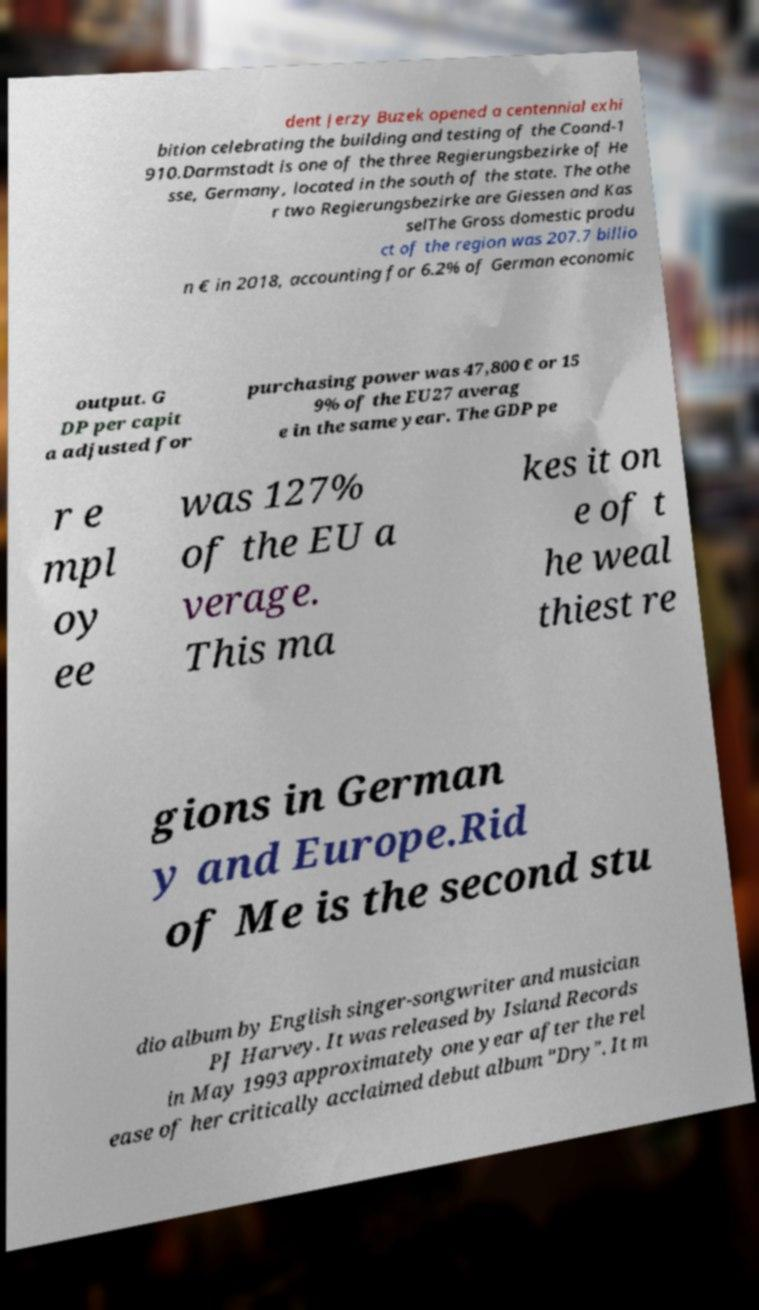For documentation purposes, I need the text within this image transcribed. Could you provide that? dent Jerzy Buzek opened a centennial exhi bition celebrating the building and testing of the Coand-1 910.Darmstadt is one of the three Regierungsbezirke of He sse, Germany, located in the south of the state. The othe r two Regierungsbezirke are Giessen and Kas selThe Gross domestic produ ct of the region was 207.7 billio n € in 2018, accounting for 6.2% of German economic output. G DP per capit a adjusted for purchasing power was 47,800 € or 15 9% of the EU27 averag e in the same year. The GDP pe r e mpl oy ee was 127% of the EU a verage. This ma kes it on e of t he weal thiest re gions in German y and Europe.Rid of Me is the second stu dio album by English singer-songwriter and musician PJ Harvey. It was released by Island Records in May 1993 approximately one year after the rel ease of her critically acclaimed debut album "Dry". It m 